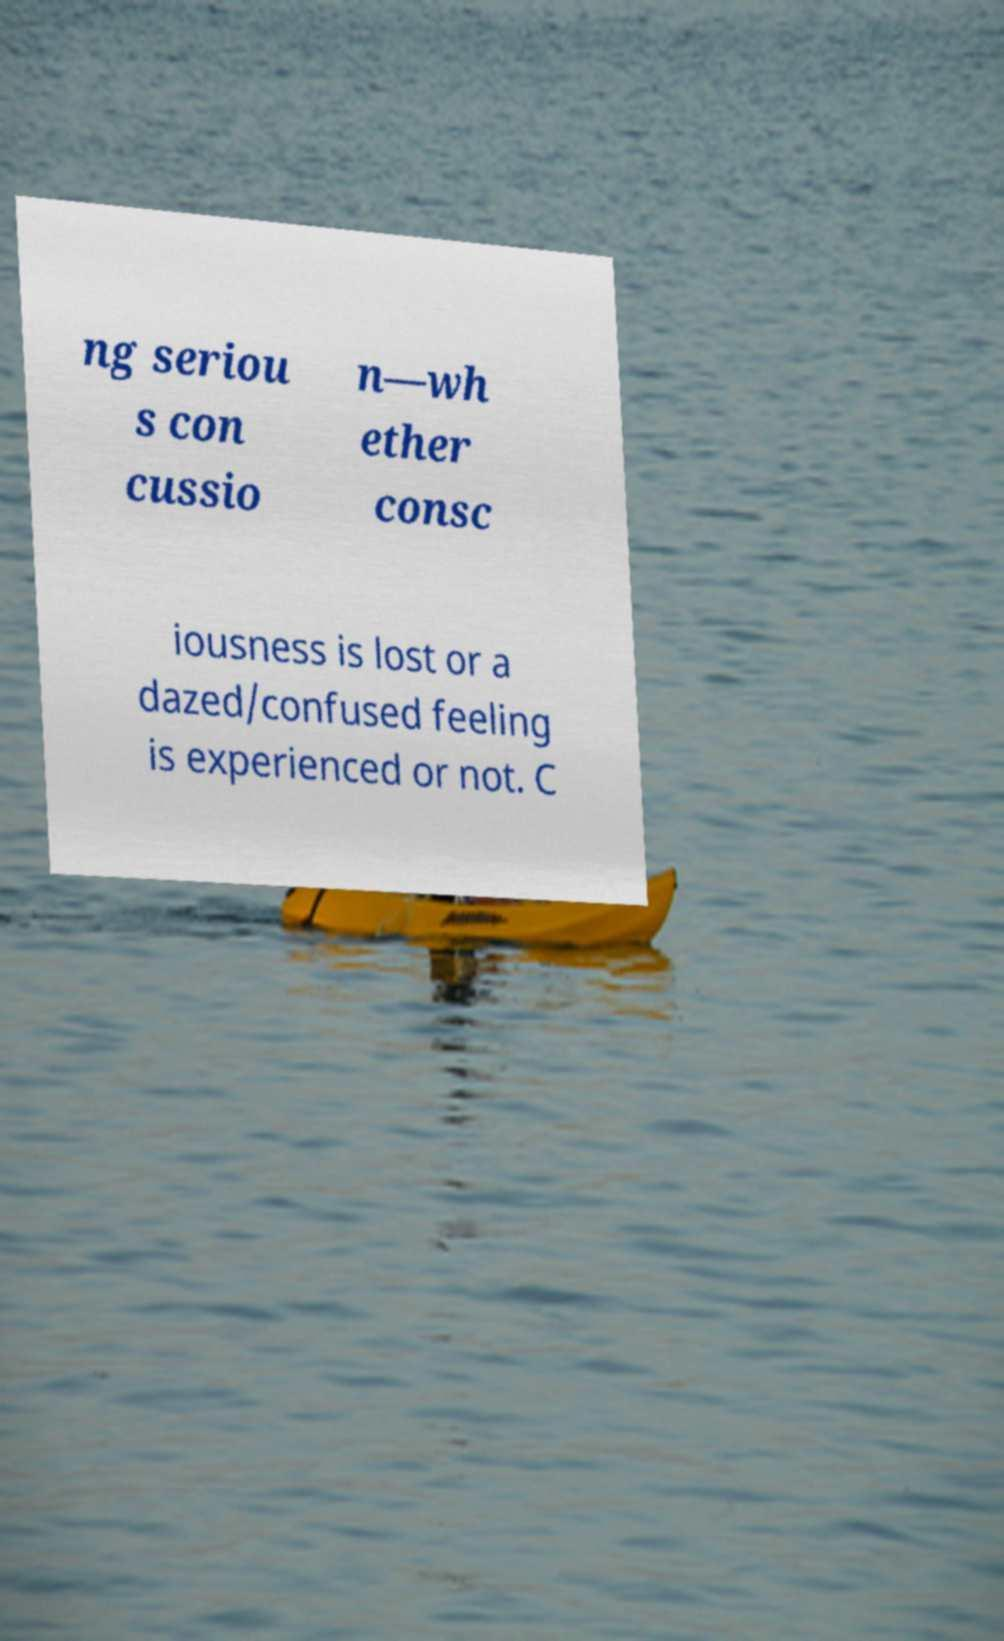Can you read and provide the text displayed in the image?This photo seems to have some interesting text. Can you extract and type it out for me? ng seriou s con cussio n—wh ether consc iousness is lost or a dazed/confused feeling is experienced or not. C 